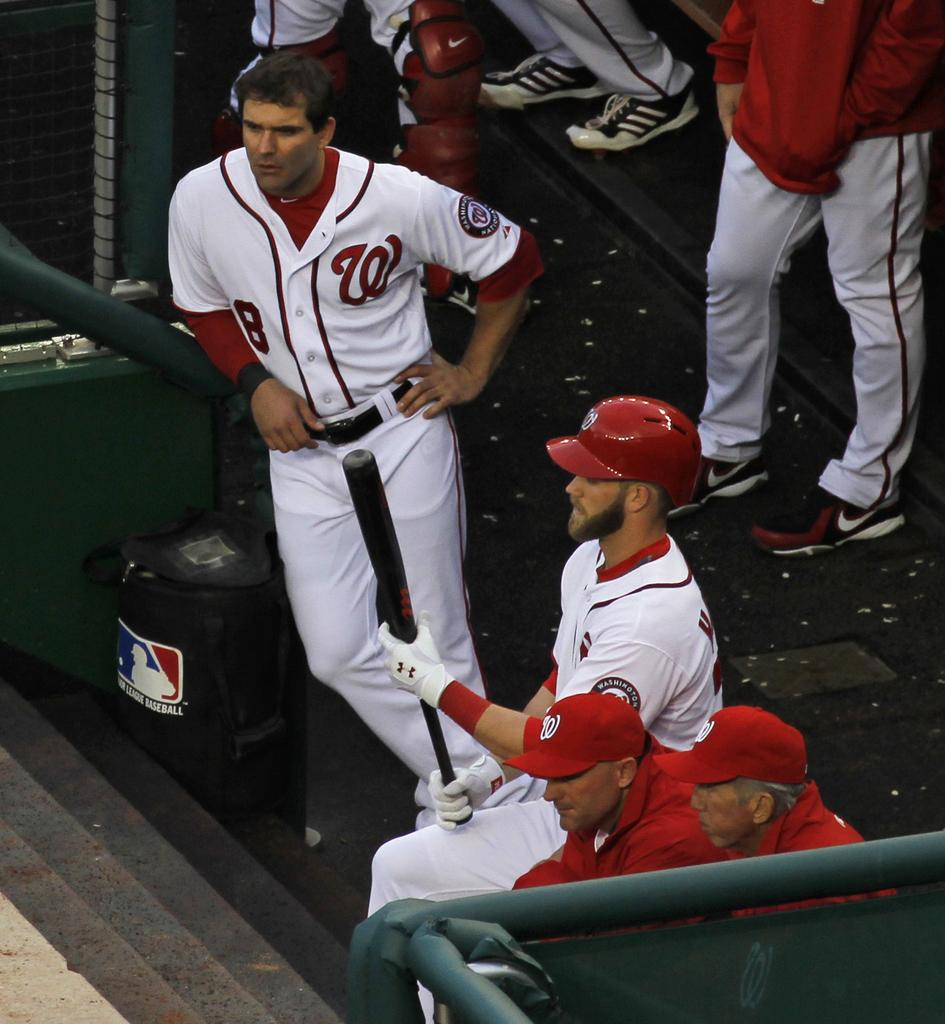<image>
Provide a brief description of the given image. Baseball team wearing red and white uniforms with a W on the right. 